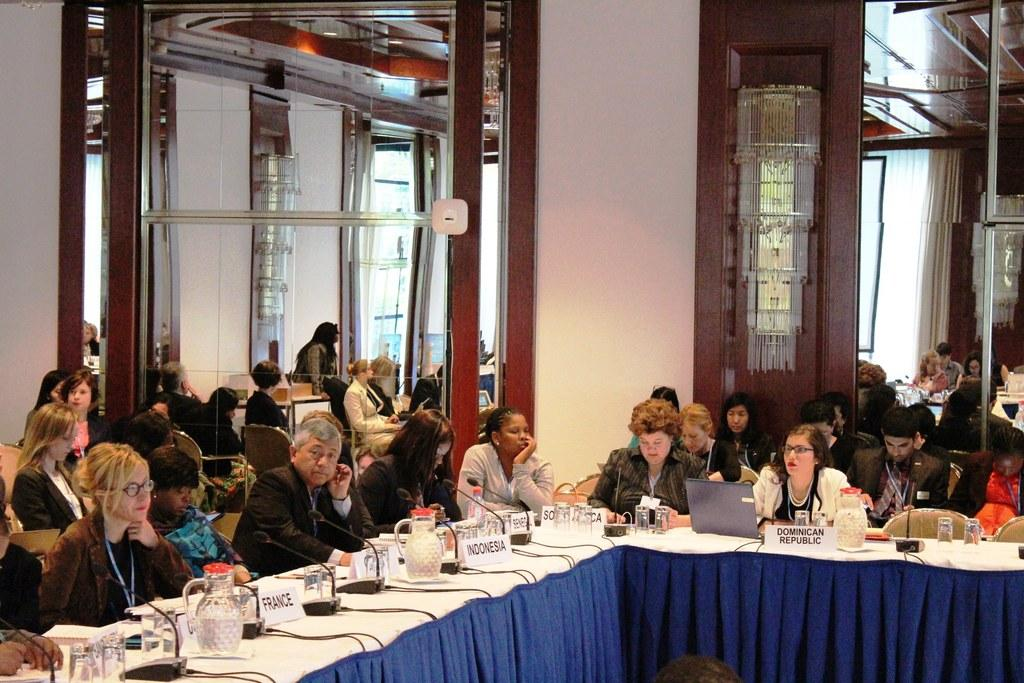What are the people in the image doing? There is a group of people sitting in chairs in the image. What is on the table in the image? There is a jug, glasses, a name paper, and a laptop on the table in the image. Can you describe the background of the image? There are other people sitting in the background, a door, and a chandelier in the background. What type of meat is being served on the cake in the image? There is no meat or cake present in the image. How much debt is being discussed in the image? There is no mention of debt in the image. 